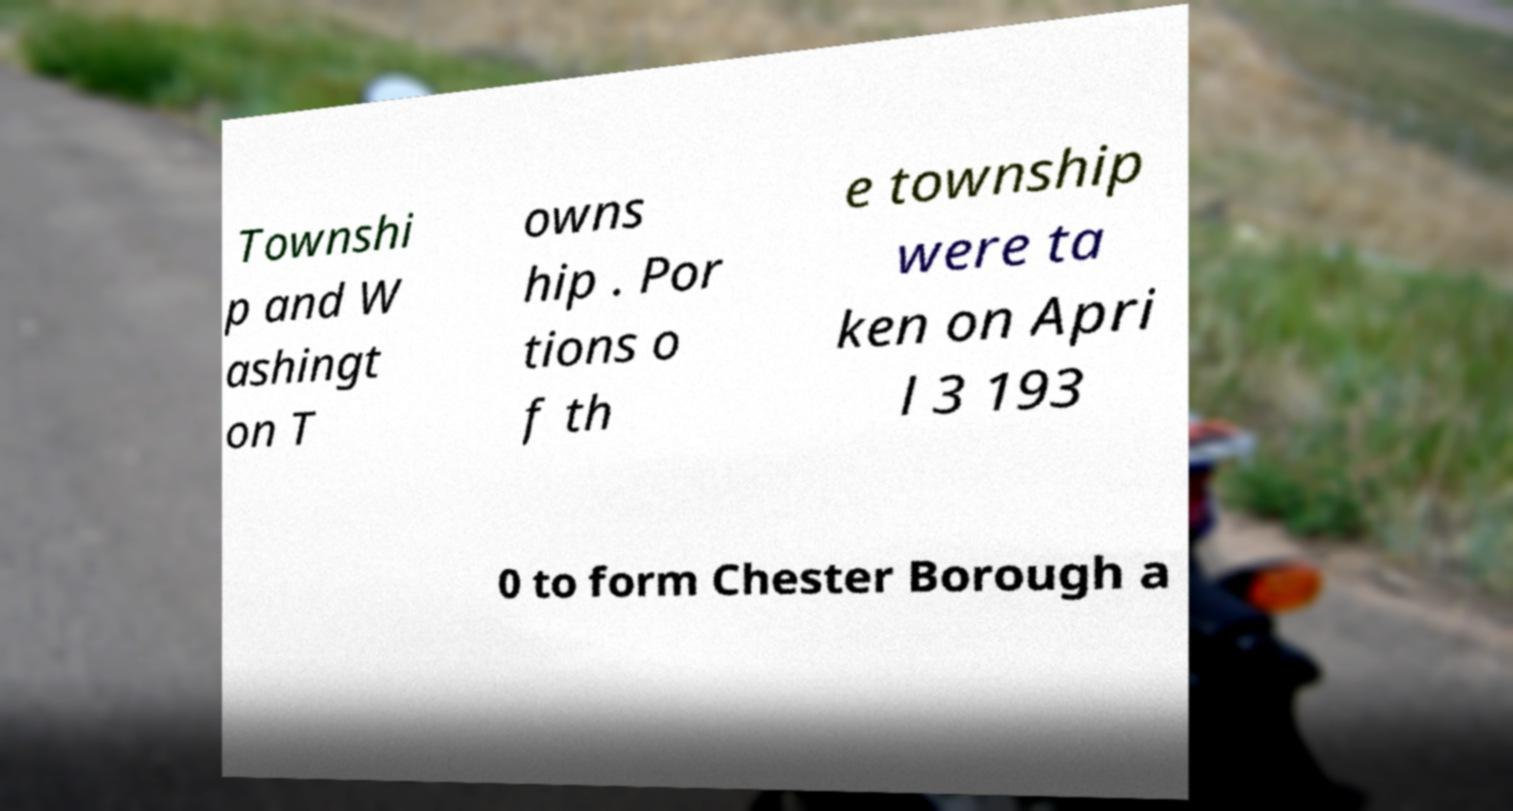There's text embedded in this image that I need extracted. Can you transcribe it verbatim? Townshi p and W ashingt on T owns hip . Por tions o f th e township were ta ken on Apri l 3 193 0 to form Chester Borough a 